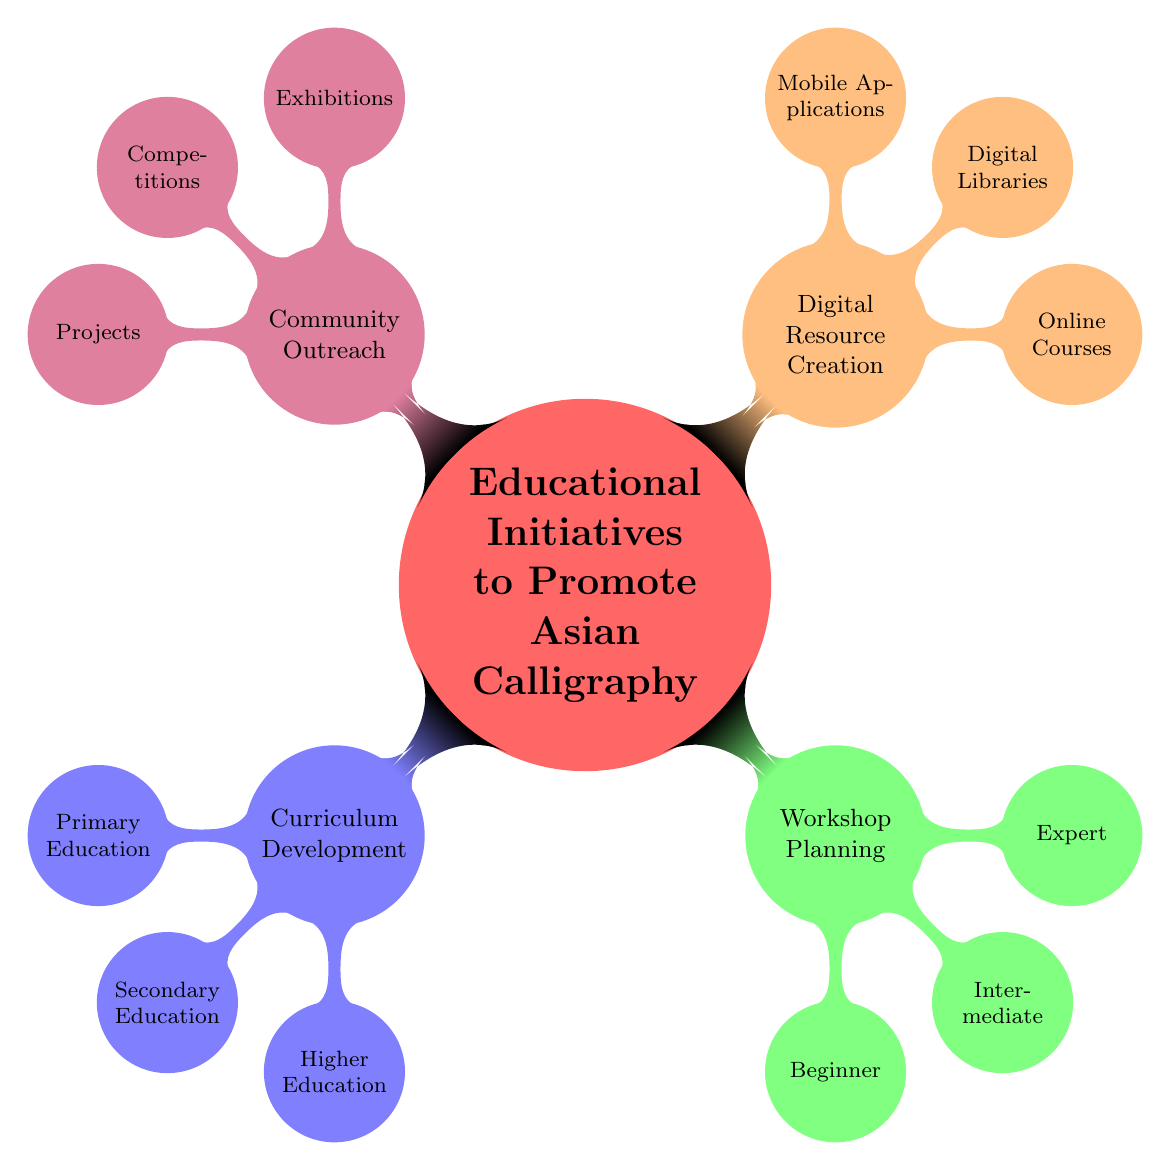What are the four main categories of initiatives? The diagram shows the central theme "Educational Initiatives to Promote Asian Calligraphy" with four main branches: Curriculum Development, Workshop Planning, Digital Resource Creation, and Community Outreach. These categories directly expand from the central node, indicating the primary focus areas.
Answer: Curriculum Development, Workshop Planning, Digital Resource Creation, Community Outreach How many types of education curricula are there? Under the "Curriculum Development" node, there are three branches: Primary Education, Secondary Education, and Higher Education. Counting these branches gives a total of three types of education curricula represented in the diagram.
Answer: 3 What is the focus of the Higher Education Curriculum? The "Higher Education Curriculum" branch contains three items: Calligraphy as an Art Form, Digital Calligraphy, and Research in Historical Calligraphy. By checking the names listed under this branch, it is clear what this educational level focuses on.
Answer: Calligraphy as an Art Form, Digital Calligraphy, Research in Historical Calligraphy What are the three types of workshops planned for expertise levels? The "Workshop Planning" section has three branches: Beginner, Intermediate, and Expert. Each of these categories relates to the level of expertise targeted by the workshops, allowing for structured learning opportunities in calligraphy.
Answer: Beginner, Intermediate, Expert Which category contains online courses as a resource? Looking at the "Digital Resource Creation" node, one of the branches listed is "Online Courses." This directly indicates that online courses are part of the resources being created to promote Asian calligraphy education.
Answer: Digital Resource Creation What are the three outreach initiatives that involve competitions? Under the "Community Outreach" category, the related branch lists "Calligraphy Competitions," which further breaks down into three specific types: School Competitions, National Calligraphy Contests, and International Calligraphy Awards. Thus, competitions are a significant part of the outreach strategy.
Answer: School Competitions, National Calligraphy Contests, International Calligraphy Awards How many items are listed under Beginner Workshops? The "Beginner Workshops" branch has three listed items: Basic Strokes and Tools, Introduction to Characters, and Hands-On Practice. By counting these items, we can see how many distinct topics are provided for beginners in calligraphy workshops.
Answer: 3 What is the significance of cultural festivals in the outreach initiatives? Within the "Calligraphy Exhibitions" subsection, cultural festivals are mentioned as a platform for showcasing calligraphy, thus signifying their role in community outreach efforts to promote cultural heritage through art.
Answer: Cultural Festivals 